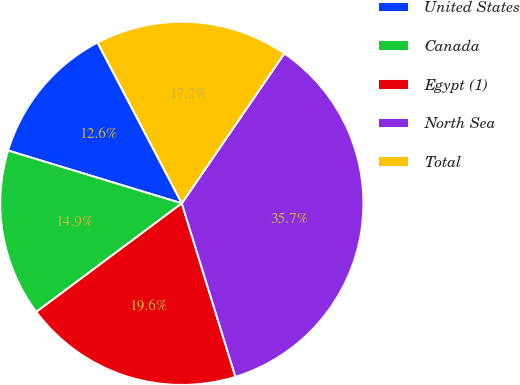<chart> <loc_0><loc_0><loc_500><loc_500><pie_chart><fcel>United States<fcel>Canada<fcel>Egypt (1)<fcel>North Sea<fcel>Total<nl><fcel>12.62%<fcel>14.9%<fcel>19.57%<fcel>35.68%<fcel>17.23%<nl></chart> 